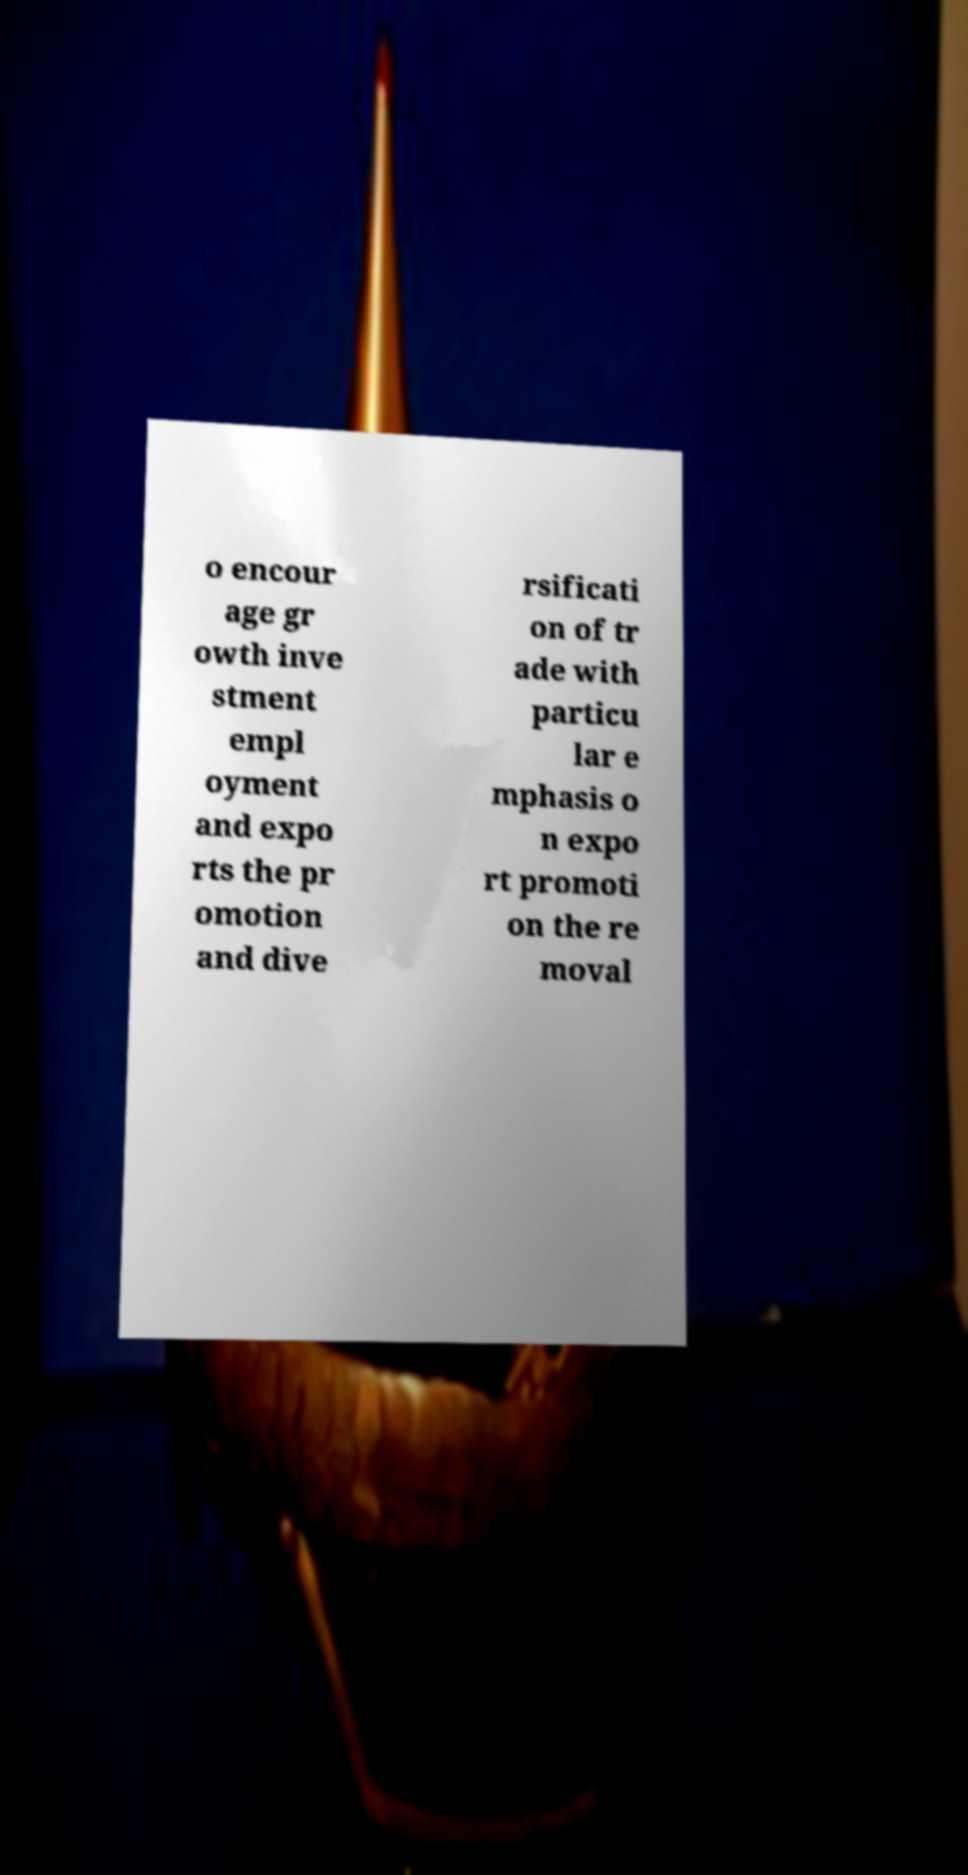What messages or text are displayed in this image? I need them in a readable, typed format. o encour age gr owth inve stment empl oyment and expo rts the pr omotion and dive rsificati on of tr ade with particu lar e mphasis o n expo rt promoti on the re moval 